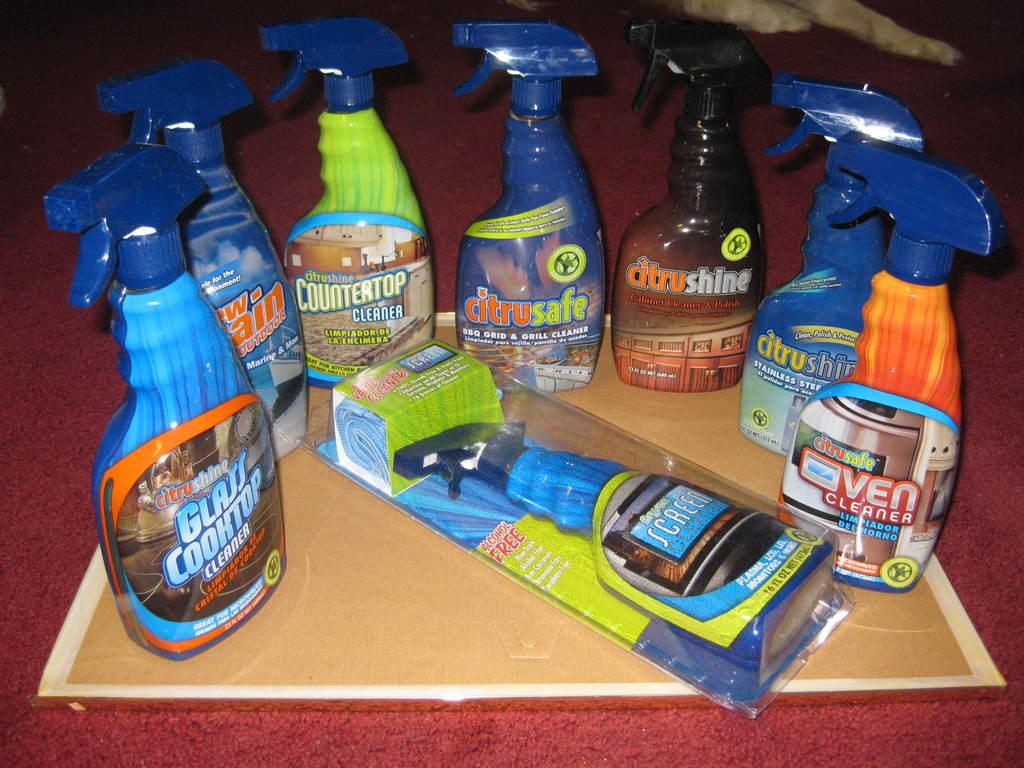What color bottle is the oven cleaner?
Offer a terse response. Orange. What color is the counter cleaner?
Provide a short and direct response. Green. 